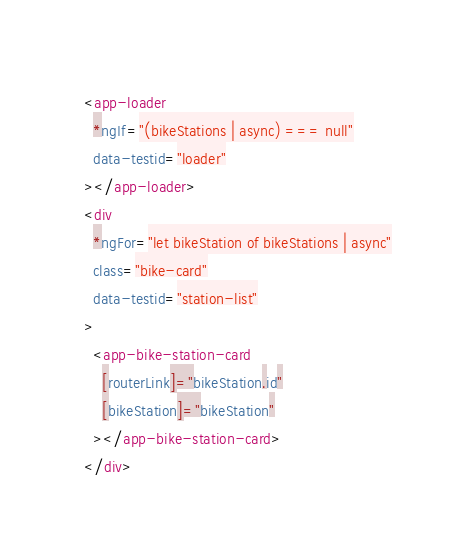<code> <loc_0><loc_0><loc_500><loc_500><_HTML_><app-loader
  *ngIf="(bikeStations | async) === null"
  data-testid="loader"
></app-loader>
<div
  *ngFor="let bikeStation of bikeStations | async"
  class="bike-card"
  data-testid="station-list"
>
  <app-bike-station-card
    [routerLink]="bikeStation.id"
    [bikeStation]="bikeStation"
  ></app-bike-station-card>
</div>
</code> 